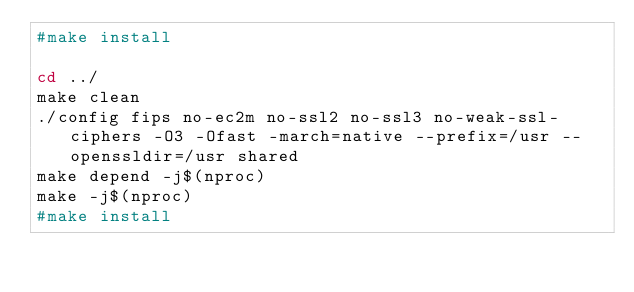Convert code to text. <code><loc_0><loc_0><loc_500><loc_500><_Bash_>#make install

cd ../
make clean
./config fips no-ec2m no-ssl2 no-ssl3 no-weak-ssl-ciphers -O3 -Ofast -march=native --prefix=/usr --openssldir=/usr shared
make depend -j$(nproc)
make -j$(nproc)
#make install
</code> 